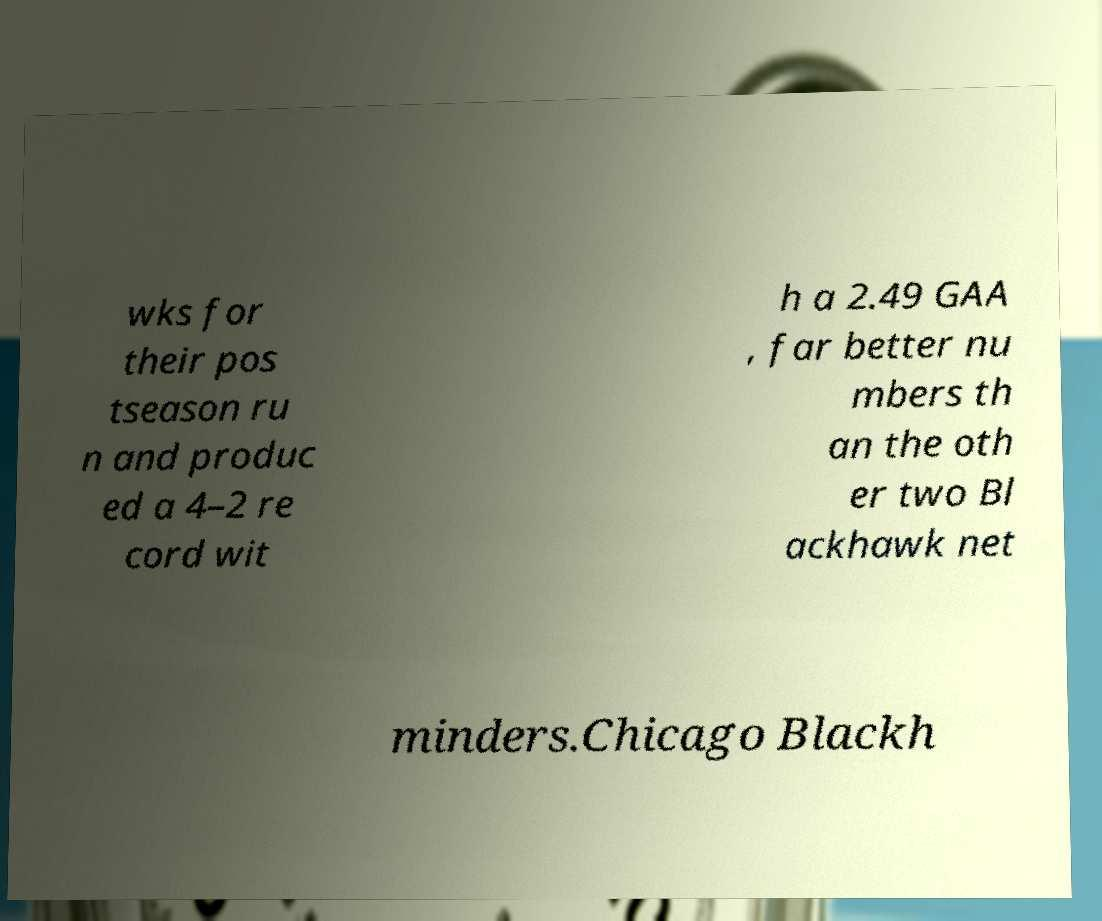There's text embedded in this image that I need extracted. Can you transcribe it verbatim? wks for their pos tseason ru n and produc ed a 4–2 re cord wit h a 2.49 GAA , far better nu mbers th an the oth er two Bl ackhawk net minders.Chicago Blackh 